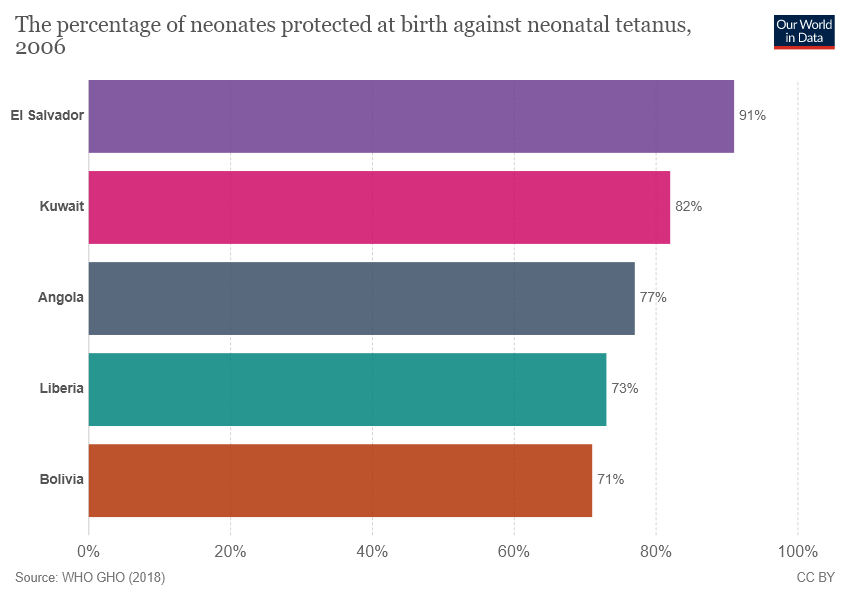Point out several critical features in this image. The average of all bars whose values are less than 80 is 73.6. The color of the bar that represents Bolivia is brown. 